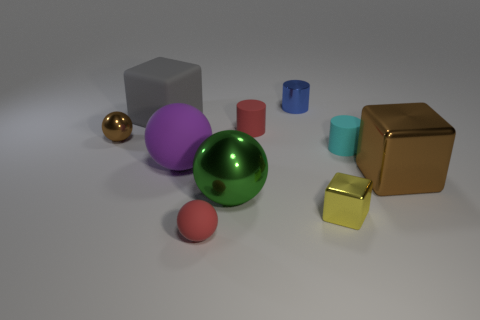The red matte object behind the large metal thing right of the tiny red thing behind the big purple thing is what shape?
Provide a succinct answer. Cylinder. What shape is the big gray thing that is made of the same material as the small cyan cylinder?
Keep it short and to the point. Cube. The purple rubber ball is what size?
Provide a succinct answer. Large. Does the matte cube have the same size as the blue cylinder?
Offer a very short reply. No. How many objects are objects on the left side of the gray cube or red things that are right of the green metal thing?
Your answer should be compact. 2. There is a tiny ball that is in front of the brown metallic thing that is to the left of the big green metal ball; how many big brown metal cubes are to the left of it?
Offer a terse response. 0. What is the size of the brown thing right of the big green metallic object?
Keep it short and to the point. Large. How many shiny spheres are the same size as the gray matte object?
Ensure brevity in your answer.  1. Does the brown sphere have the same size as the cube that is on the left side of the tiny red rubber cylinder?
Give a very brief answer. No. How many objects are yellow shiny cubes or large brown matte cylinders?
Your answer should be compact. 1. 